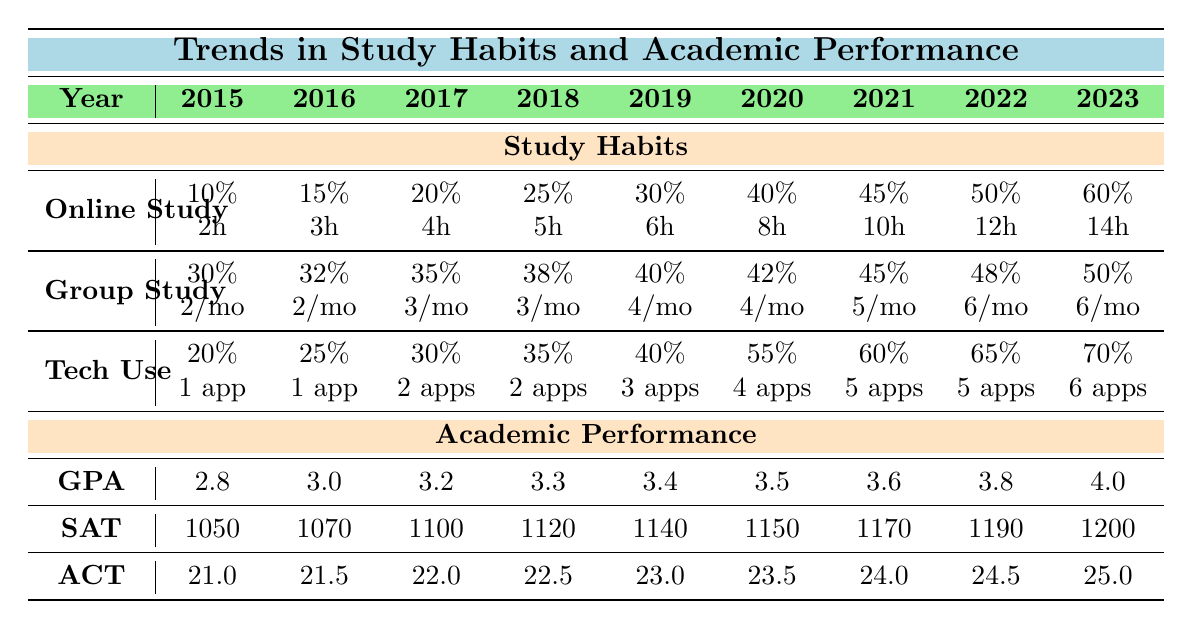What was the percentage of online study hours in 2015? The table lists the data for online study hours for each year. In 2015, it shows 10%.
Answer: 10% How many average hours per week did students study online in 2023? The average hours per week of online study for 2023 is listed as 14 hours.
Answer: 14 hours Did the use of technology resources increase each year? The percentage of students using technology resources steadily increased from 20% in 2015 to 70% in 2023, indicating a consistent increase each year.
Answer: Yes What was the average GPA in 2019? The table shows the average GPA for 2019 is listed as 3.4.
Answer: 3.4 How many average group study sessions per month were recorded in 2020? According to the table, the average group study sessions per month in 2020 was 4 sessions.
Answer: 4 sessions What was the difference in SAT average scores between 2015 and 2023? The SAT average score in 2015 was 1050, and in 2023 it was 1200. The difference is calculated as 1200 - 1050 = 150.
Answer: 150 What percentage of students engaged in group study in 2022? The table indicates that 48% of students engaged in group study in 2022.
Answer: 48% If a student increased their online study hours by 2 hours each year starting from 2015, how many hours would they study online in 2021? Starting from 2 hours in 2015 and increasing by 2 hours each year, by 2021 (6 years later) they would study 2 + (2 * 6) = 14 hours.
Answer: 14 hours What trend can be observed in the average ACT scores over the years? The average ACT scores show a consistent upward trend from 21.0 in 2015 to 25.0 in 2023, indicating improvement in scores over the years.
Answer: Increasing trend In which year did the average GPA first surpass 3.5? The table shows the GPA first surpassed 3.5 in 2021, when the average GPA was recorded at 3.6.
Answer: 2021 What was the average number of apps used for study in 2018? The table shows that the average number of apps used for study in 2018 was 2 apps.
Answer: 2 apps What was the rate of increase in online study hours from 2015 to 2023? The increase in online study hours from 2 hours in 2015 to 14 hours in 2023 is calculated by (14 - 2) = 12 hours over 8 years, an average increase of 1.5 hours per year.
Answer: 12 hours increase Was the percentage of students using technology resources over 50% in any year? Yes, the percentage of students using technology resources was over 50% starting in 2020 (55%) and continued to rise to 70% by 2023.
Answer: Yes What is the average of all SAT average scores from 2015 to 2023? To find the average SAT scores from 2015 to 2023, sum the scores (1050 + 1070 + 1100 + 1120 + 1140 + 1150 + 1170 + 1190 + 1200 = 10100) and divide by 9 (10100 / 9 = 1122.22).
Answer: Approximately 1122.22 